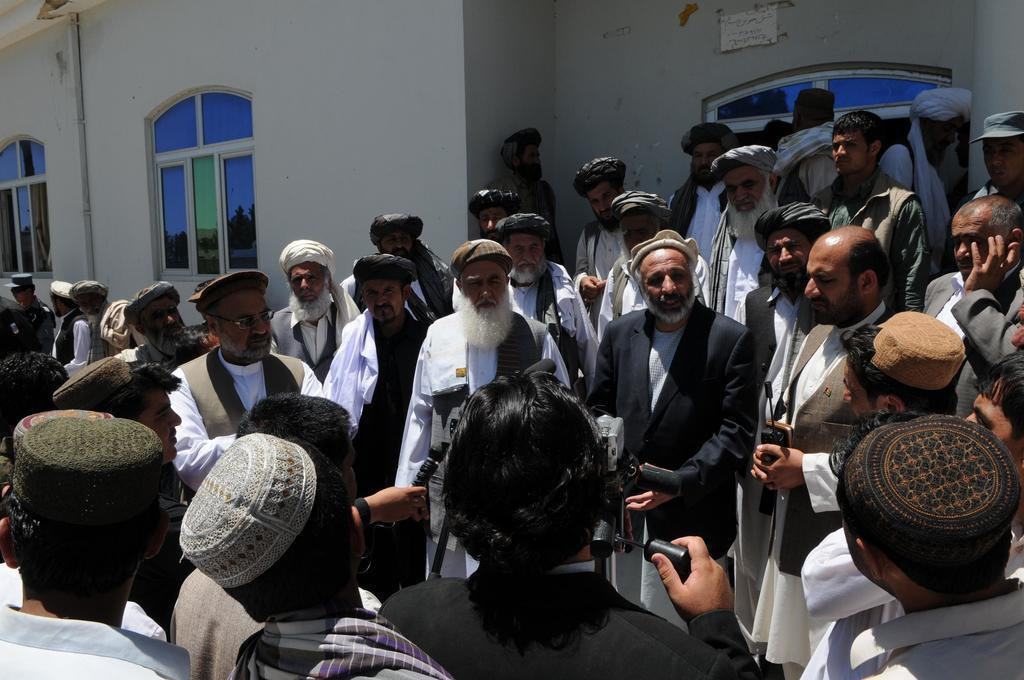How many people are present in the image? There are many people in the image. What are some of the people doing in the image? Some people are holding objects in their hands. What type of structure can be seen in the image? There is a building in the image. What feature of the building is mentioned in the facts? The building has windows. What type of alarm can be heard going off in the image? There is no alarm present in the image, and therefore no sound can be heard. Can you describe the girl in the image? There is no girl mentioned in the facts provided, so we cannot describe her. 